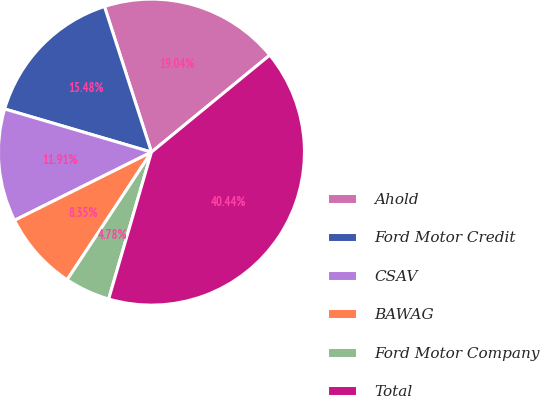Convert chart to OTSL. <chart><loc_0><loc_0><loc_500><loc_500><pie_chart><fcel>Ahold<fcel>Ford Motor Credit<fcel>CSAV<fcel>BAWAG<fcel>Ford Motor Company<fcel>Total<nl><fcel>19.04%<fcel>15.48%<fcel>11.91%<fcel>8.35%<fcel>4.78%<fcel>40.44%<nl></chart> 